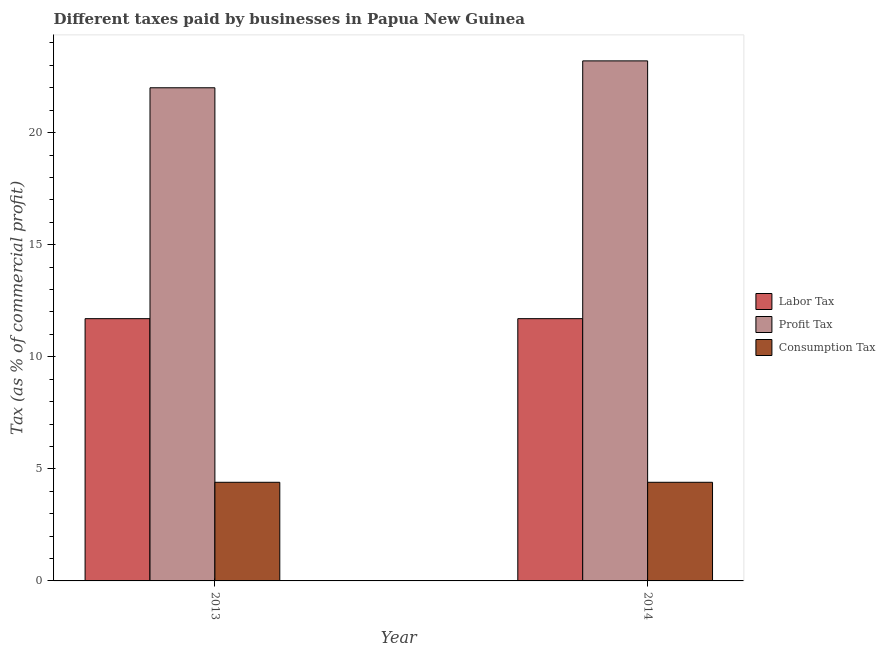How many groups of bars are there?
Your answer should be compact. 2. Are the number of bars per tick equal to the number of legend labels?
Provide a short and direct response. Yes. How many bars are there on the 1st tick from the right?
Offer a terse response. 3. In how many cases, is the number of bars for a given year not equal to the number of legend labels?
Your response must be concise. 0. What is the percentage of profit tax in 2014?
Keep it short and to the point. 23.2. Across all years, what is the maximum percentage of consumption tax?
Your answer should be very brief. 4.4. Across all years, what is the minimum percentage of labor tax?
Provide a succinct answer. 11.7. In which year was the percentage of labor tax maximum?
Your answer should be compact. 2013. What is the total percentage of consumption tax in the graph?
Provide a succinct answer. 8.8. What is the difference between the percentage of profit tax in 2013 and that in 2014?
Offer a terse response. -1.2. What is the average percentage of consumption tax per year?
Your answer should be very brief. 4.4. In the year 2013, what is the difference between the percentage of consumption tax and percentage of profit tax?
Ensure brevity in your answer.  0. What is the ratio of the percentage of profit tax in 2013 to that in 2014?
Give a very brief answer. 0.95. What does the 3rd bar from the left in 2013 represents?
Keep it short and to the point. Consumption Tax. What does the 1st bar from the right in 2013 represents?
Provide a succinct answer. Consumption Tax. Are all the bars in the graph horizontal?
Provide a succinct answer. No. How many years are there in the graph?
Your answer should be compact. 2. Where does the legend appear in the graph?
Keep it short and to the point. Center right. How many legend labels are there?
Provide a short and direct response. 3. What is the title of the graph?
Keep it short and to the point. Different taxes paid by businesses in Papua New Guinea. What is the label or title of the Y-axis?
Your answer should be compact. Tax (as % of commercial profit). What is the Tax (as % of commercial profit) in Labor Tax in 2013?
Make the answer very short. 11.7. What is the Tax (as % of commercial profit) of Consumption Tax in 2013?
Give a very brief answer. 4.4. What is the Tax (as % of commercial profit) in Labor Tax in 2014?
Offer a terse response. 11.7. What is the Tax (as % of commercial profit) in Profit Tax in 2014?
Keep it short and to the point. 23.2. What is the Tax (as % of commercial profit) in Consumption Tax in 2014?
Give a very brief answer. 4.4. Across all years, what is the maximum Tax (as % of commercial profit) in Labor Tax?
Make the answer very short. 11.7. Across all years, what is the maximum Tax (as % of commercial profit) in Profit Tax?
Offer a terse response. 23.2. Across all years, what is the minimum Tax (as % of commercial profit) of Profit Tax?
Offer a terse response. 22. What is the total Tax (as % of commercial profit) in Labor Tax in the graph?
Offer a very short reply. 23.4. What is the total Tax (as % of commercial profit) of Profit Tax in the graph?
Your response must be concise. 45.2. What is the difference between the Tax (as % of commercial profit) in Profit Tax in 2013 and that in 2014?
Your response must be concise. -1.2. What is the difference between the Tax (as % of commercial profit) in Consumption Tax in 2013 and that in 2014?
Offer a terse response. 0. What is the difference between the Tax (as % of commercial profit) of Labor Tax in 2013 and the Tax (as % of commercial profit) of Profit Tax in 2014?
Keep it short and to the point. -11.5. What is the difference between the Tax (as % of commercial profit) of Profit Tax in 2013 and the Tax (as % of commercial profit) of Consumption Tax in 2014?
Your response must be concise. 17.6. What is the average Tax (as % of commercial profit) in Profit Tax per year?
Ensure brevity in your answer.  22.6. What is the average Tax (as % of commercial profit) in Consumption Tax per year?
Your response must be concise. 4.4. In the year 2014, what is the difference between the Tax (as % of commercial profit) of Profit Tax and Tax (as % of commercial profit) of Consumption Tax?
Ensure brevity in your answer.  18.8. What is the ratio of the Tax (as % of commercial profit) in Profit Tax in 2013 to that in 2014?
Provide a succinct answer. 0.95. What is the difference between the highest and the lowest Tax (as % of commercial profit) of Profit Tax?
Your answer should be very brief. 1.2. What is the difference between the highest and the lowest Tax (as % of commercial profit) in Consumption Tax?
Ensure brevity in your answer.  0. 